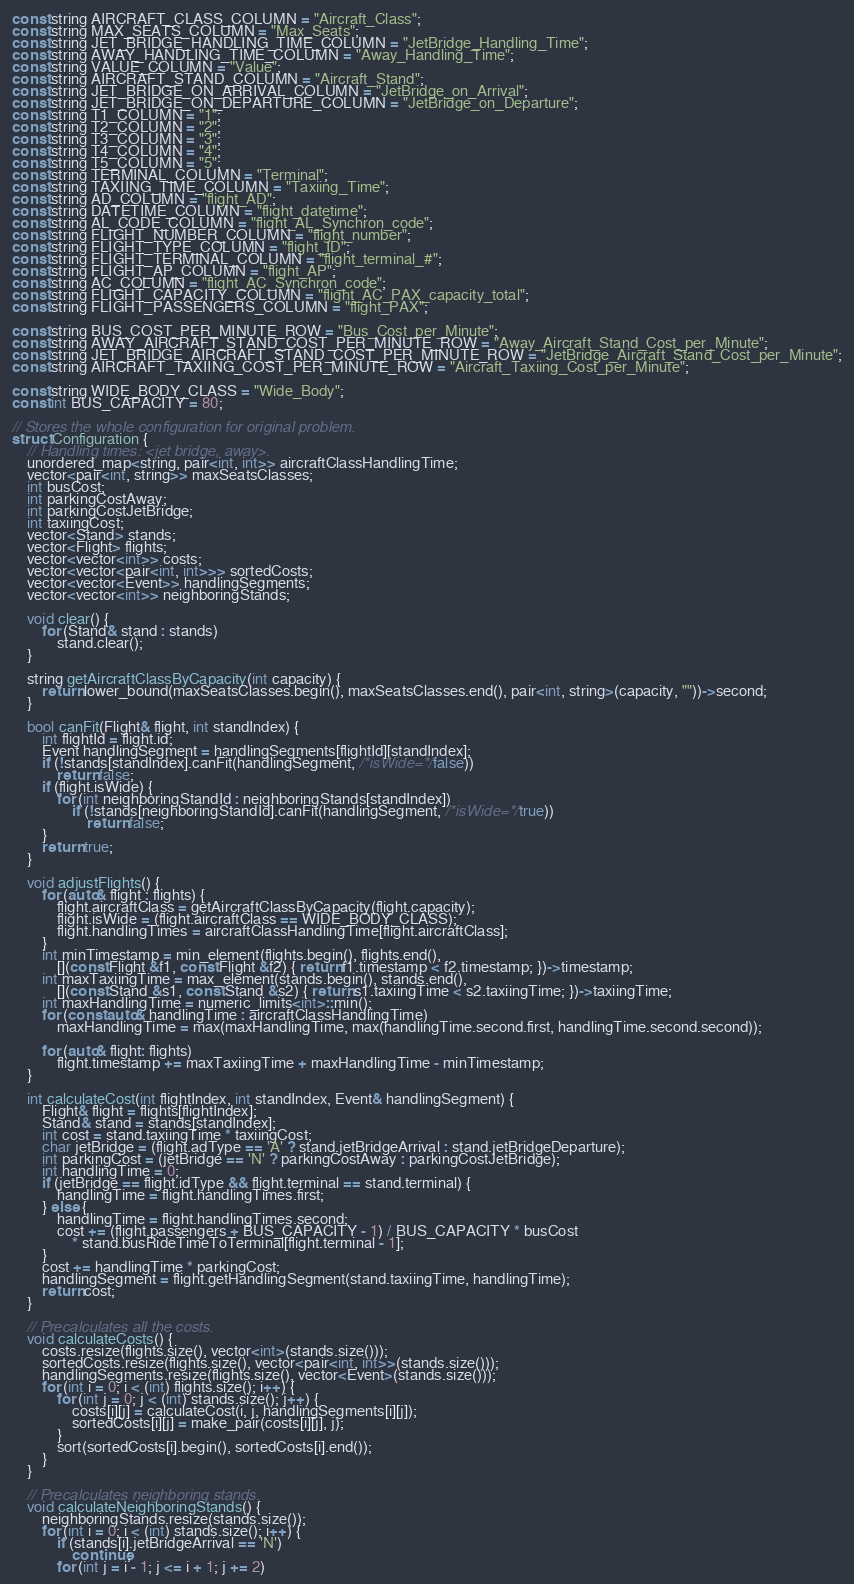<code> <loc_0><loc_0><loc_500><loc_500><_C_>const string AIRCRAFT_CLASS_COLUMN = "Aircraft_Class";
const string MAX_SEATS_COLUMN = "Max_Seats";
const string JET_BRIDGE_HANDLING_TIME_COLUMN = "JetBridge_Handling_Time";
const string AWAY_HANDLING_TIME_COLUMN = "Away_Handling_Time";
const string VALUE_COLUMN = "Value";
const string AIRCRAFT_STAND_COLUMN = "Aircraft_Stand";
const string JET_BRIDGE_ON_ARRIVAL_COLUMN = "JetBridge_on_Arrival";
const string JET_BRIDGE_ON_DEPARTURE_COLUMN = "JetBridge_on_Departure";
const string T1_COLUMN = "1";
const string T2_COLUMN = "2";
const string T3_COLUMN = "3";
const string T4_COLUMN = "4";
const string T5_COLUMN = "5";
const string TERMINAL_COLUMN = "Terminal";
const string TAXIING_TIME_COLUMN = "Taxiing_Time";
const string AD_COLUMN = "flight_AD";
const string DATETIME_COLUMN = "flight_datetime";
const string AL_CODE_COLUMN = "flight_AL_Synchron_code";
const string FLIGHT_NUMBER_COLUMN = "flight_number";
const string FLIGHT_TYPE_COLUMN = "flight_ID";
const string FLIGHT_TERMINAL_COLUMN = "flight_terminal_#";
const string FLIGHT_AP_COLUMN = "flight_AP"; 
const string AC_COLUMN = "flight_AC_Synchron_code"; 
const string FLIGHT_CAPACITY_COLUMN = "flight_AC_PAX_capacity_total";
const string FLIGHT_PASSENGERS_COLUMN = "flight_PAX";

const string BUS_COST_PER_MINUTE_ROW = "Bus_Cost_per_Minute";
const string AWAY_AIRCRAFT_STAND_COST_PER_MINUTE_ROW = "Away_Aircraft_Stand_Cost_per_Minute";
const string JET_BRIDGE_AIRCRAFT_STAND_COST_PER_MINUTE_ROW = "JetBridge_Aircraft_Stand_Cost_per_Minute";
const string AIRCRAFT_TAXIING_COST_PER_MINUTE_ROW = "Aircraft_Taxiing_Cost_per_Minute";

const string WIDE_BODY_CLASS = "Wide_Body";
const int BUS_CAPACITY = 80;

// Stores the whole configuration for original problem.
struct Configuration {
	// Handling times: <jet bridge, away>.
	unordered_map<string, pair<int, int>> aircraftClassHandlingTime;
	vector<pair<int, string>> maxSeatsClasses;
	int busCost;
	int parkingCostAway;
	int parkingCostJetBridge;
	int taxiingCost;
	vector<Stand> stands;
	vector<Flight> flights;
	vector<vector<int>> costs;
	vector<vector<pair<int, int>>> sortedCosts;
	vector<vector<Event>> handlingSegments;
	vector<vector<int>> neighboringStands;
	
	void clear() {
		for (Stand& stand : stands)
			stand.clear();
	}

	string getAircraftClassByCapacity(int capacity) {
		return lower_bound(maxSeatsClasses.begin(), maxSeatsClasses.end(), pair<int, string>(capacity, ""))->second;
	}

	bool canFit(Flight& flight, int standIndex) {
		int flightId = flight.id;
		Event handlingSegment = handlingSegments[flightId][standIndex];
		if (!stands[standIndex].canFit(handlingSegment, /*isWide=*/false))
			return false;
		if (flight.isWide) {
			for (int neighboringStandId : neighboringStands[standIndex])
				if (!stands[neighboringStandId].canFit(handlingSegment, /*isWide=*/true))
					return false;
		}
		return true;
	}

	void adjustFlights() {
		for (auto& flight : flights) {
			flight.aircraftClass = getAircraftClassByCapacity(flight.capacity);
			flight.isWide = (flight.aircraftClass == WIDE_BODY_CLASS);
			flight.handlingTimes = aircraftClassHandlingTime[flight.aircraftClass];
		}
		int minTimestamp = min_element(flights.begin(), flights.end(), 
			[](const Flight &f1, const Flight &f2) { return f1.timestamp < f2.timestamp; })->timestamp;
		int maxTaxiingTime = max_element(stands.begin(), stands.end(), 
			[](const Stand &s1, const Stand &s2) { return s1.taxiingTime < s2.taxiingTime; })->taxiingTime;
		int maxHandlingTime = numeric_limits<int>::min();
		for (const auto& handlingTime : aircraftClassHandlingTime)
			maxHandlingTime = max(maxHandlingTime, max(handlingTime.second.first, handlingTime.second.second));
		
		for (auto& flight: flights)
			flight.timestamp += maxTaxiingTime + maxHandlingTime - minTimestamp;
	}

	int calculateCost(int flightIndex, int standIndex, Event& handlingSegment) {
		Flight& flight = flights[flightIndex];
		Stand& stand = stands[standIndex];
		int cost = stand.taxiingTime * taxiingCost;
		char jetBridge = (flight.adType == 'A' ? stand.jetBridgeArrival : stand.jetBridgeDeparture);
		int parkingCost = (jetBridge == 'N' ? parkingCostAway : parkingCostJetBridge); 
		int handlingTime = 0;
		if (jetBridge == flight.idType && flight.terminal == stand.terminal) {
			handlingTime = flight.handlingTimes.first;
		} else {
			handlingTime = flight.handlingTimes.second;
			cost += (flight.passengers + BUS_CAPACITY - 1) / BUS_CAPACITY * busCost 
				* stand.busRideTimeToTerminal[flight.terminal - 1];
		}
		cost += handlingTime * parkingCost;
		handlingSegment = flight.getHandlingSegment(stand.taxiingTime, handlingTime);
		return cost;
	}

	// Precalculates all the costs.
	void calculateCosts() {
		costs.resize(flights.size(), vector<int>(stands.size()));
		sortedCosts.resize(flights.size(), vector<pair<int, int>>(stands.size()));
		handlingSegments.resize(flights.size(), vector<Event>(stands.size()));
		for (int i = 0; i < (int) flights.size(); i++) {
			for (int j = 0; j < (int) stands.size(); j++) {
				costs[i][j] = calculateCost(i, j, handlingSegments[i][j]);
				sortedCosts[i][j] = make_pair(costs[i][j], j);
			}
			sort(sortedCosts[i].begin(), sortedCosts[i].end());
		}
	}

	// Precalculates neighboring stands.
	void calculateNeighboringStands() {
		neighboringStands.resize(stands.size());
		for (int i = 0; i < (int) stands.size(); i++) {
			if (stands[i].jetBridgeArrival == 'N')
				continue;
			for (int j = i - 1; j <= i + 1; j += 2)</code> 